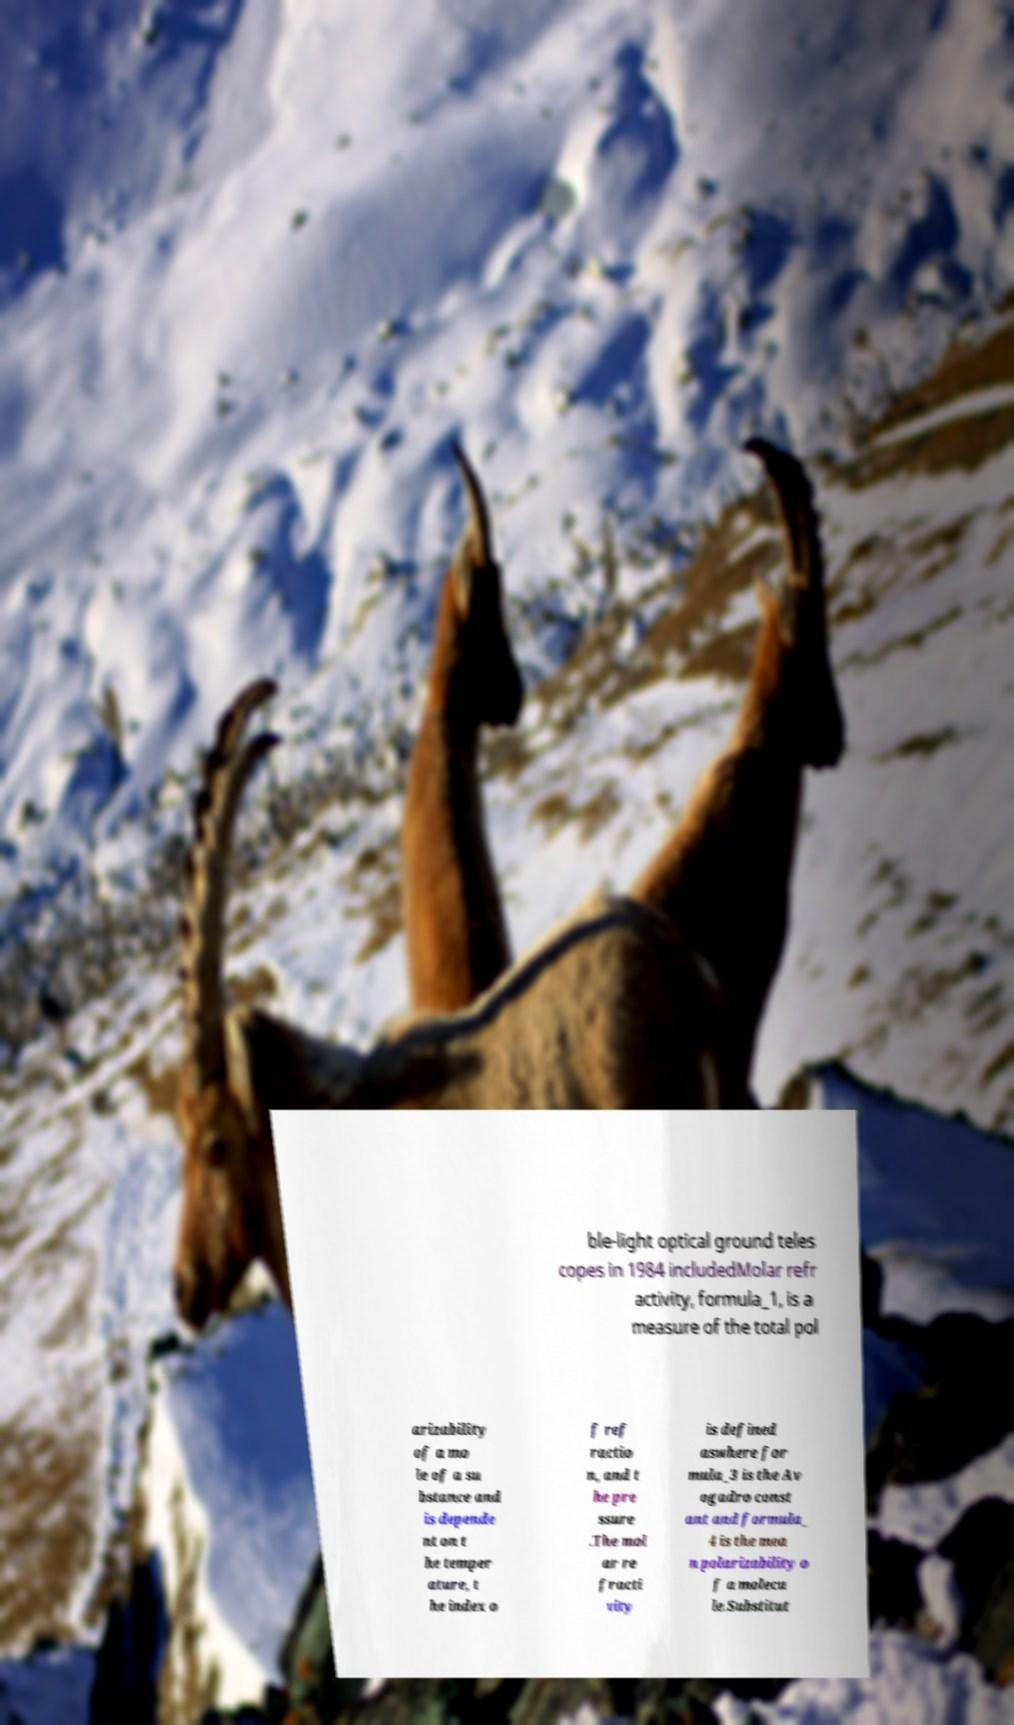Could you extract and type out the text from this image? ble-light optical ground teles copes in 1984 includedMolar refr activity, formula_1, is a measure of the total pol arizability of a mo le of a su bstance and is depende nt on t he temper ature, t he index o f ref ractio n, and t he pre ssure .The mol ar re fracti vity is defined aswhere for mula_3 is the Av ogadro const ant and formula_ 4 is the mea n polarizability o f a molecu le.Substitut 